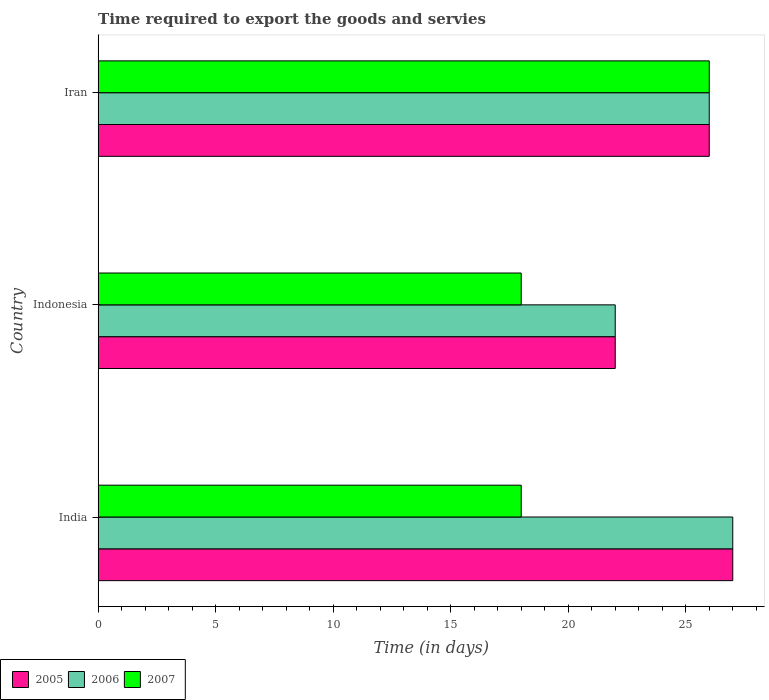How many groups of bars are there?
Your answer should be compact. 3. Are the number of bars on each tick of the Y-axis equal?
Your answer should be very brief. Yes. What is the number of days required to export the goods and services in 2005 in Indonesia?
Make the answer very short. 22. Across all countries, what is the minimum number of days required to export the goods and services in 2007?
Your response must be concise. 18. What is the difference between the number of days required to export the goods and services in 2006 in Iran and the number of days required to export the goods and services in 2005 in Indonesia?
Your answer should be very brief. 4. What is the average number of days required to export the goods and services in 2007 per country?
Offer a very short reply. 20.67. In how many countries, is the number of days required to export the goods and services in 2006 greater than 19 days?
Make the answer very short. 3. What is the ratio of the number of days required to export the goods and services in 2005 in India to that in Indonesia?
Keep it short and to the point. 1.23. Is the number of days required to export the goods and services in 2006 in India less than that in Iran?
Provide a succinct answer. No. What is the difference between the highest and the lowest number of days required to export the goods and services in 2006?
Offer a terse response. 5. In how many countries, is the number of days required to export the goods and services in 2007 greater than the average number of days required to export the goods and services in 2007 taken over all countries?
Provide a succinct answer. 1. Is the sum of the number of days required to export the goods and services in 2005 in India and Indonesia greater than the maximum number of days required to export the goods and services in 2006 across all countries?
Provide a succinct answer. Yes. What does the 3rd bar from the top in Indonesia represents?
Give a very brief answer. 2005. What does the 1st bar from the bottom in India represents?
Ensure brevity in your answer.  2005. Are all the bars in the graph horizontal?
Your answer should be very brief. Yes. How many countries are there in the graph?
Offer a terse response. 3. What is the difference between two consecutive major ticks on the X-axis?
Keep it short and to the point. 5. Does the graph contain any zero values?
Offer a terse response. No. Does the graph contain grids?
Provide a succinct answer. No. How many legend labels are there?
Your answer should be compact. 3. How are the legend labels stacked?
Provide a succinct answer. Horizontal. What is the title of the graph?
Ensure brevity in your answer.  Time required to export the goods and servies. What is the label or title of the X-axis?
Keep it short and to the point. Time (in days). What is the Time (in days) in 2006 in India?
Make the answer very short. 27. What is the Time (in days) in 2005 in Indonesia?
Offer a terse response. 22. What is the Time (in days) in 2007 in Indonesia?
Give a very brief answer. 18. What is the Time (in days) of 2005 in Iran?
Your response must be concise. 26. Across all countries, what is the minimum Time (in days) of 2005?
Provide a short and direct response. 22. What is the difference between the Time (in days) in 2006 in India and that in Indonesia?
Your answer should be compact. 5. What is the difference between the Time (in days) of 2007 in India and that in Indonesia?
Make the answer very short. 0. What is the difference between the Time (in days) of 2005 in India and that in Iran?
Provide a short and direct response. 1. What is the difference between the Time (in days) in 2007 in India and that in Iran?
Provide a short and direct response. -8. What is the difference between the Time (in days) of 2006 in Indonesia and that in Iran?
Offer a very short reply. -4. What is the difference between the Time (in days) in 2007 in Indonesia and that in Iran?
Your answer should be very brief. -8. What is the difference between the Time (in days) of 2005 in India and the Time (in days) of 2006 in Indonesia?
Make the answer very short. 5. What is the difference between the Time (in days) in 2005 in India and the Time (in days) in 2007 in Indonesia?
Offer a very short reply. 9. What is the difference between the Time (in days) of 2006 in India and the Time (in days) of 2007 in Indonesia?
Make the answer very short. 9. What is the difference between the Time (in days) of 2006 in India and the Time (in days) of 2007 in Iran?
Ensure brevity in your answer.  1. What is the difference between the Time (in days) in 2005 in Indonesia and the Time (in days) in 2006 in Iran?
Provide a succinct answer. -4. What is the average Time (in days) in 2005 per country?
Ensure brevity in your answer.  25. What is the average Time (in days) of 2007 per country?
Offer a very short reply. 20.67. What is the difference between the Time (in days) in 2005 and Time (in days) in 2006 in India?
Give a very brief answer. 0. What is the difference between the Time (in days) of 2006 and Time (in days) of 2007 in India?
Make the answer very short. 9. What is the difference between the Time (in days) of 2005 and Time (in days) of 2006 in Indonesia?
Provide a short and direct response. 0. What is the difference between the Time (in days) of 2006 and Time (in days) of 2007 in Indonesia?
Offer a very short reply. 4. What is the difference between the Time (in days) in 2005 and Time (in days) in 2007 in Iran?
Provide a short and direct response. 0. What is the ratio of the Time (in days) in 2005 in India to that in Indonesia?
Make the answer very short. 1.23. What is the ratio of the Time (in days) of 2006 in India to that in Indonesia?
Keep it short and to the point. 1.23. What is the ratio of the Time (in days) of 2005 in India to that in Iran?
Keep it short and to the point. 1.04. What is the ratio of the Time (in days) of 2007 in India to that in Iran?
Make the answer very short. 0.69. What is the ratio of the Time (in days) in 2005 in Indonesia to that in Iran?
Your response must be concise. 0.85. What is the ratio of the Time (in days) in 2006 in Indonesia to that in Iran?
Provide a succinct answer. 0.85. What is the ratio of the Time (in days) in 2007 in Indonesia to that in Iran?
Keep it short and to the point. 0.69. What is the difference between the highest and the second highest Time (in days) of 2007?
Offer a terse response. 8. What is the difference between the highest and the lowest Time (in days) of 2005?
Ensure brevity in your answer.  5. 